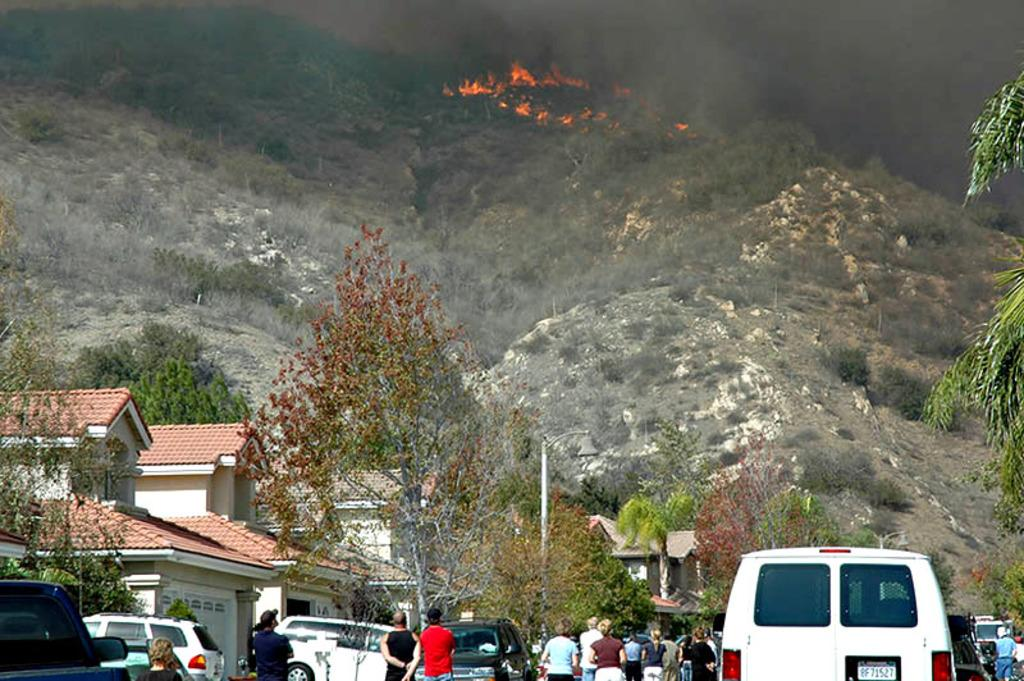What is happening in the forest in the image? There is a fire in the forest. Are there any people present in the image? Yes, people are observing the fire. What type of humor can be seen in the image? There is no humor present in the image; it depicts a fire in the forest and people observing it. 